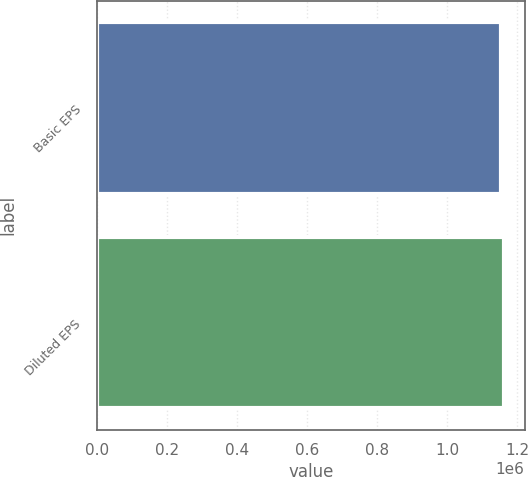Convert chart. <chart><loc_0><loc_0><loc_500><loc_500><bar_chart><fcel>Basic EPS<fcel>Diluted EPS<nl><fcel>1.1517e+06<fcel>1.16202e+06<nl></chart> 